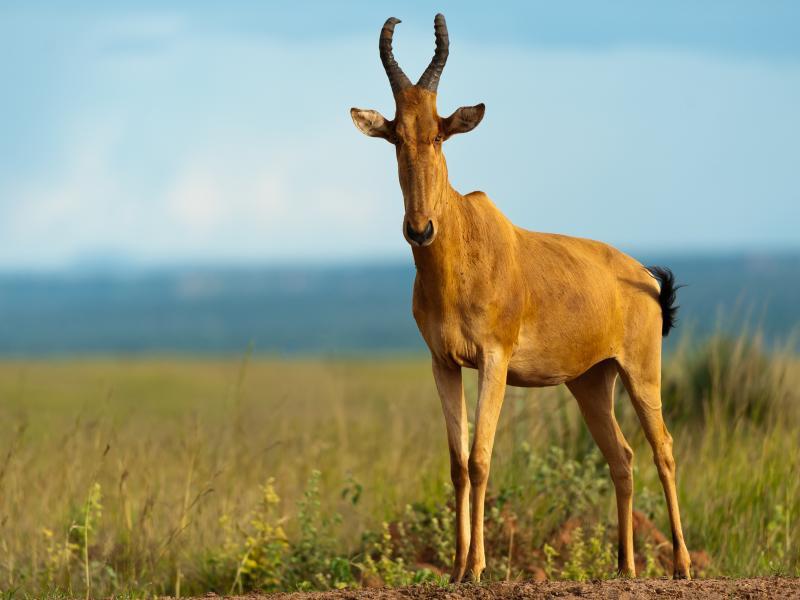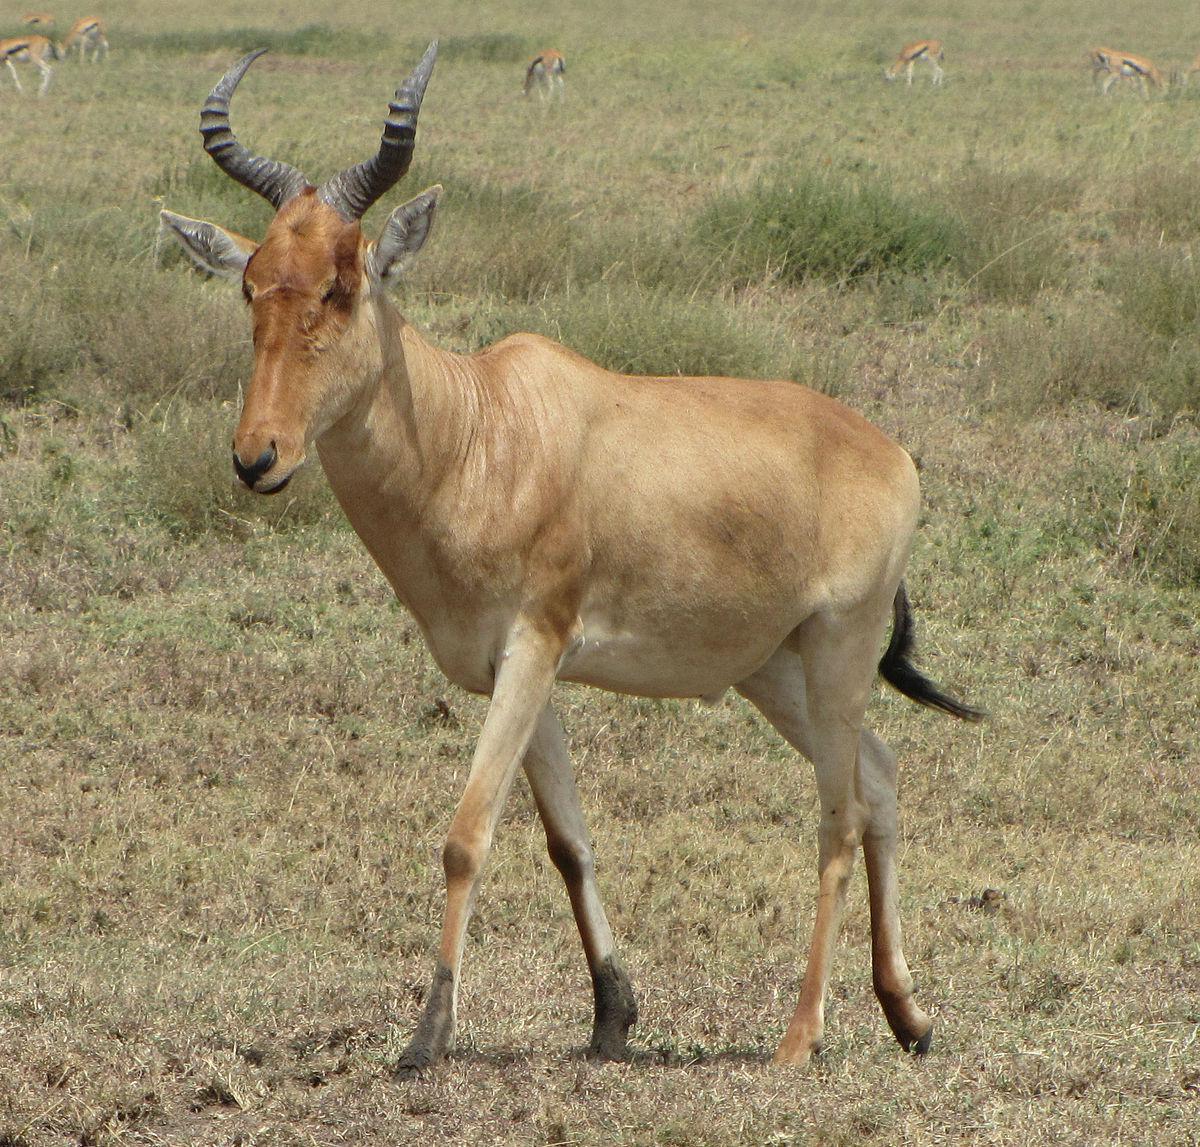The first image is the image on the left, the second image is the image on the right. Considering the images on both sides, is "At least 7 hartebeests walk down a dirt road." valid? Answer yes or no. No. The first image is the image on the left, the second image is the image on the right. Considering the images on both sides, is "There are only two horned animals standing outside, one in each image." valid? Answer yes or no. Yes. 